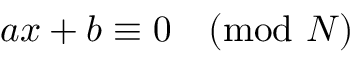<formula> <loc_0><loc_0><loc_500><loc_500>a x + b \equiv 0 { \pmod { N } }</formula> 